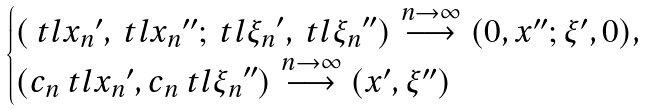Convert formula to latex. <formula><loc_0><loc_0><loc_500><loc_500>\begin{cases} ( \ t l { x _ { n } } ^ { \prime } , \ t l { x _ { n } } ^ { \prime \prime } ; \ t l { \xi _ { n } } ^ { \prime } , \ t l { \xi _ { n } } ^ { \prime \prime } ) \overset { n \to \infty } { \longrightarrow } ( 0 , x ^ { \prime \prime } ; \xi ^ { \prime } , 0 ) , \\ ( c _ { n } \ t l { x _ { n } } ^ { \prime } , c _ { n } \ t l { \xi _ { n } } ^ { \prime \prime } ) \overset { n \to \infty } { \longrightarrow } ( x ^ { \prime } , \xi ^ { \prime \prime } ) \end{cases}</formula> 